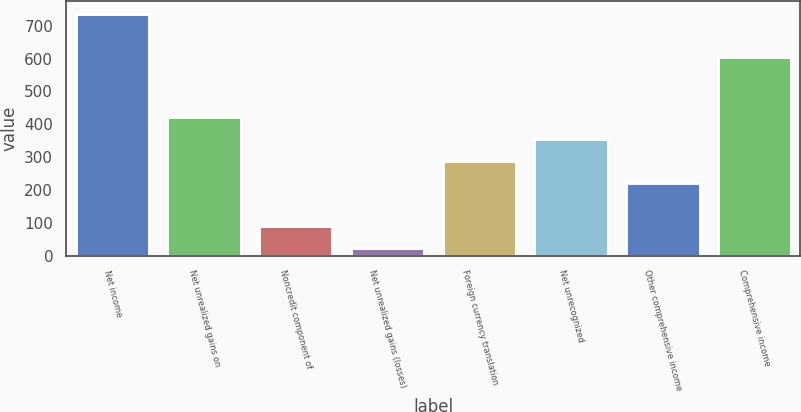Convert chart to OTSL. <chart><loc_0><loc_0><loc_500><loc_500><bar_chart><fcel>Net income<fcel>Net unrealized gains on<fcel>Noncredit component of<fcel>Net unrealized gains (losses)<fcel>Foreign currency translation<fcel>Net unrecognized<fcel>Other comprehensive income<fcel>Comprehensive income<nl><fcel>737.06<fcel>422.78<fcel>90.13<fcel>23.6<fcel>289.72<fcel>356.25<fcel>223.19<fcel>604<nl></chart> 